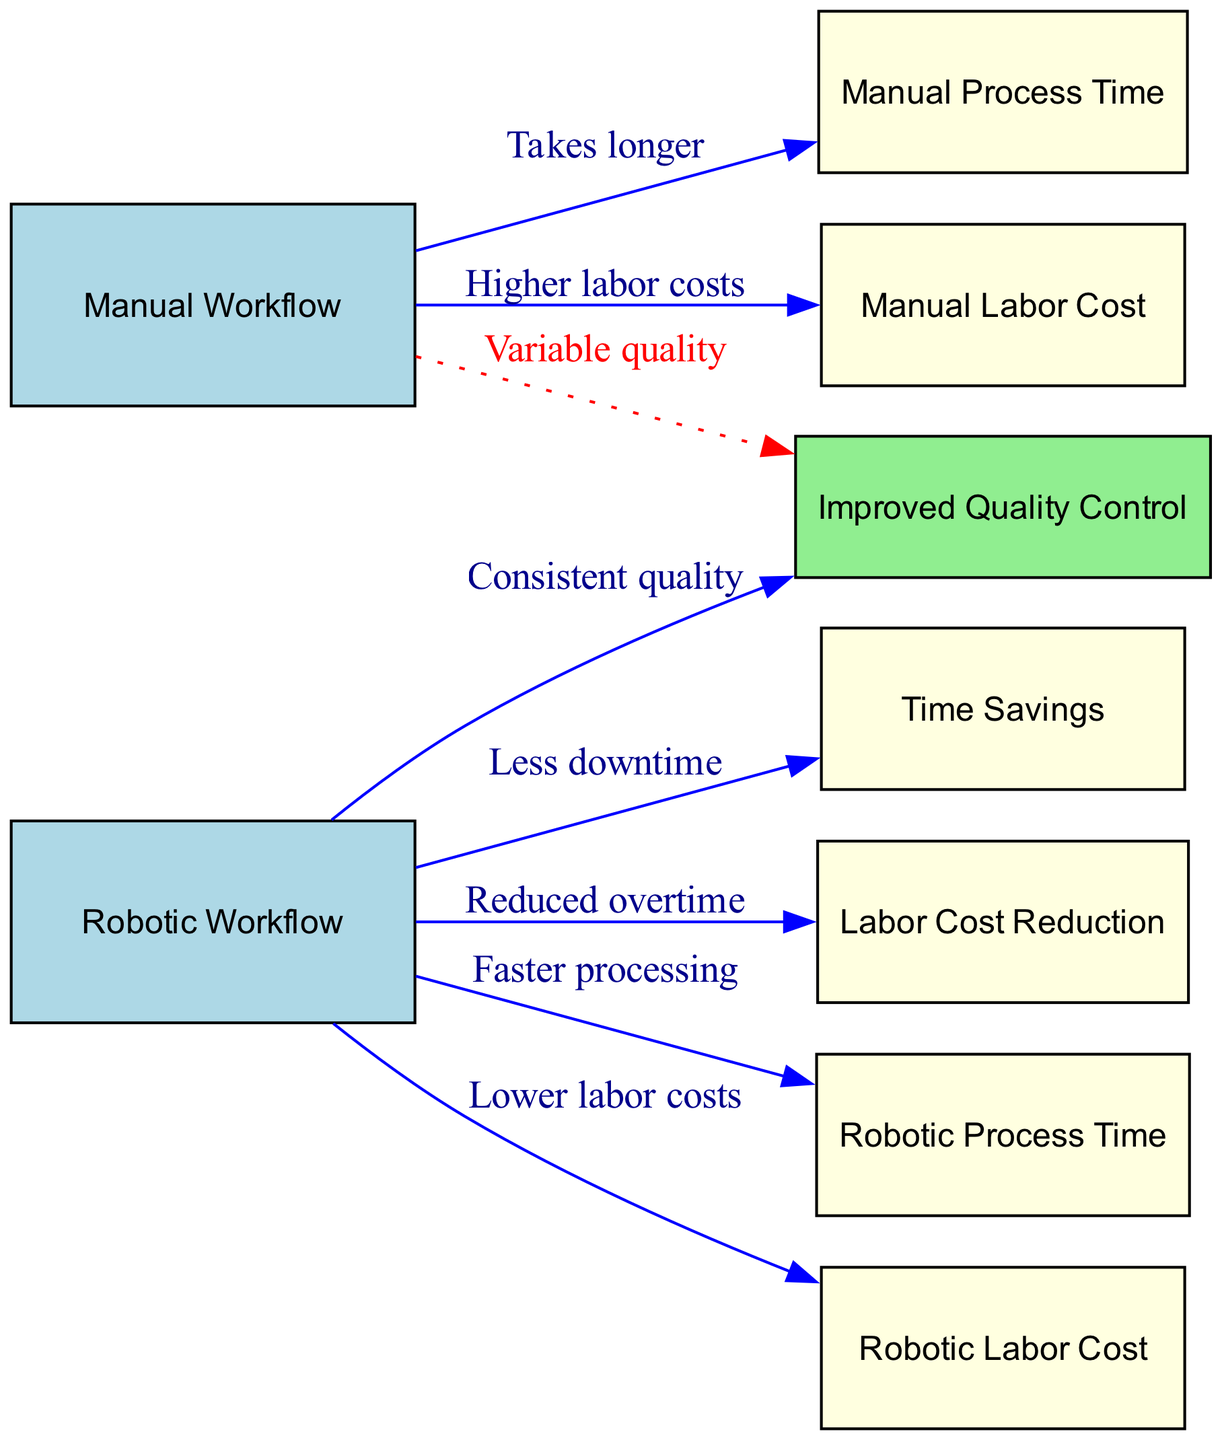What's the relationship between manual workflow and manual process time? The diagram shows an edge from "Manual Workflow" to "Manual Process Time" with the label "Takes longer," indicating that the manual workflow leads to longer processing times.
Answer: Takes longer What does the robotic workflow lead to regarding labor costs? There is an edge from "Robotic Workflow" to "Robotic Labor Cost" with the label "Lower labor costs," indicating that the robotic workflow results in reduced labor costs.
Answer: Lower labor costs How many nodes are in the diagram? By counting the entries under the "nodes" section, there are eight nodes total: manualWorkflow, roboticWorkflow, timeSavings, laborCostReduction, manualProcessTime, roboticProcessTime, manualLaborCost, roboticLaborCost, and improvedQualityControl.
Answer: Eight What is one benefit of the robotic workflow related to quality? The diagram indicates that "Robotic Workflow" leads to "Improved Quality Control" with the label "Consistent quality," suggesting that the use of robotics ensures better quality compared to manual processes.
Answer: Consistent quality What does the dotted line indicate between manual workflow and improved quality control? The diagram has a dotted edge from "Manual Workflow" to "Improved Quality Control" labeled "Variable quality," suggesting that the quality from the manual workflow is inconsistent or varies.
Answer: Variable quality What saves time in the robotic workflow? The diagram points out that "Robotic Workflow" to "Time Savings" is connected with the label "Less downtime," implying that less downtime during robotic processing contributes to time savings.
Answer: Less downtime How does the robotic workflow affect overtime? The diagram shows that "Robotic Workflow" leads to "Labor Cost Reduction" with the label "Reduced overtime," indicating that the implementation of robotic systems reduces the need for overtime work.
Answer: Reduced overtime What represents a difference in processing times between workflows? The difference is illustrated by "Manual Process Time" being connected to "Manual Workflow" with "Takes longer" and "Robotic Process Time" showing "Faster processing," indicating that robotic processing times are quicker than manual.
Answer: Faster processing 